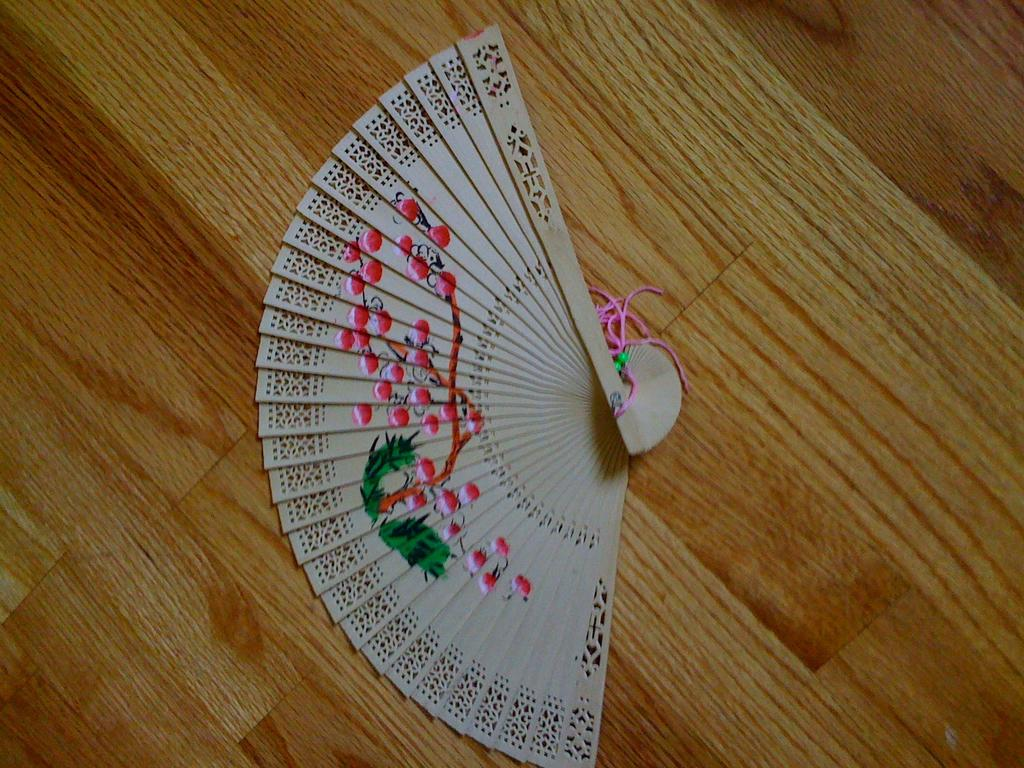What is the main subject of the image? There is an object in the image. What material is the object made of? The object is made of wood. What is attached to the object? There is thread on the object. What type of noise can be heard coming from the glass in the image? There is no glass present in the image, so it is not possible to determine what, if any, noise might be heard. 